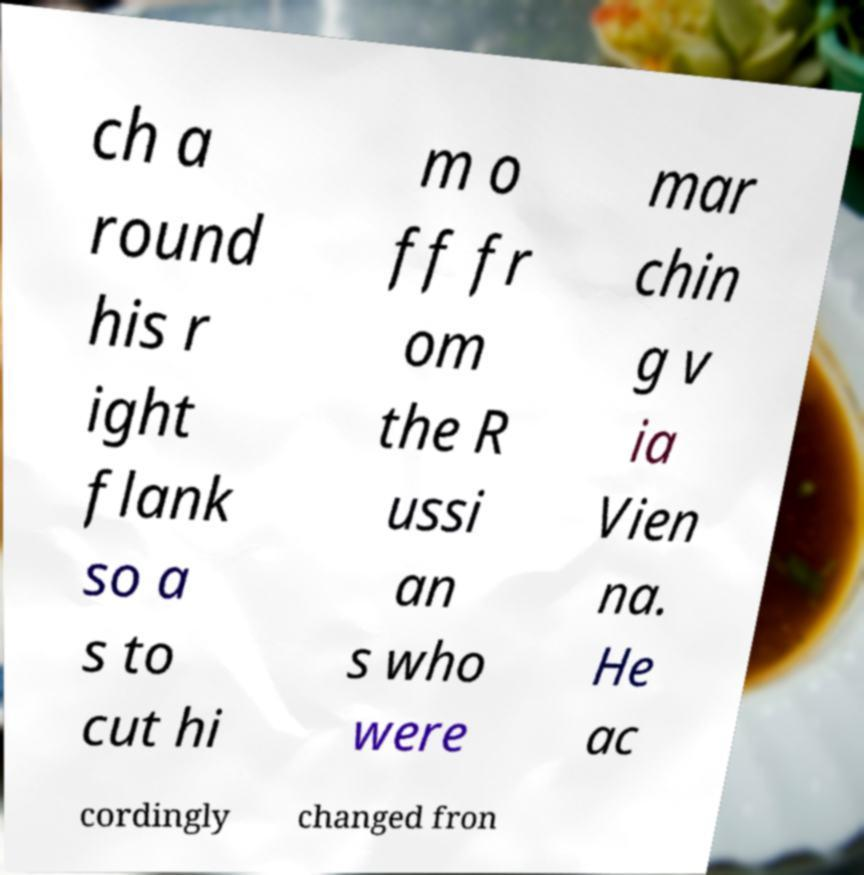What messages or text are displayed in this image? I need them in a readable, typed format. ch a round his r ight flank so a s to cut hi m o ff fr om the R ussi an s who were mar chin g v ia Vien na. He ac cordingly changed fron 